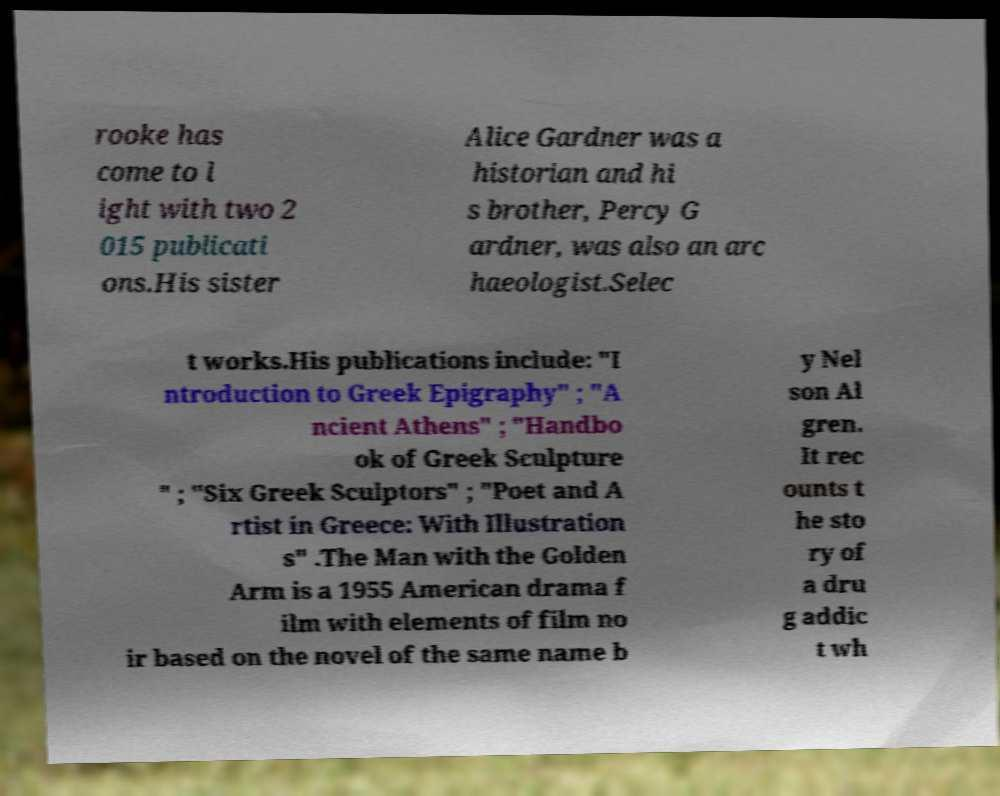For documentation purposes, I need the text within this image transcribed. Could you provide that? rooke has come to l ight with two 2 015 publicati ons.His sister Alice Gardner was a historian and hi s brother, Percy G ardner, was also an arc haeologist.Selec t works.His publications include: "I ntroduction to Greek Epigraphy" ; "A ncient Athens" ; "Handbo ok of Greek Sculpture " ; "Six Greek Sculptors" ; "Poet and A rtist in Greece: With Illustration s" .The Man with the Golden Arm is a 1955 American drama f ilm with elements of film no ir based on the novel of the same name b y Nel son Al gren. It rec ounts t he sto ry of a dru g addic t wh 